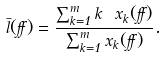<formula> <loc_0><loc_0><loc_500><loc_500>\bar { l } ( \alpha ) = \frac { \sum _ { k = 1 } ^ { m } k \ x _ { k } ( \alpha ) } { \sum _ { k = 1 } ^ { m } x _ { k } ( \alpha ) } .</formula> 